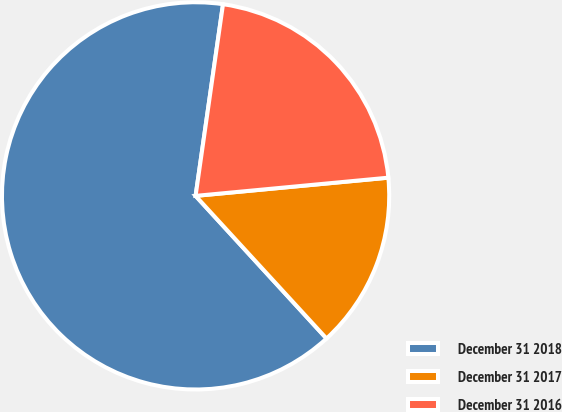<chart> <loc_0><loc_0><loc_500><loc_500><pie_chart><fcel>December 31 2018<fcel>December 31 2017<fcel>December 31 2016<nl><fcel>64.08%<fcel>14.68%<fcel>21.24%<nl></chart> 